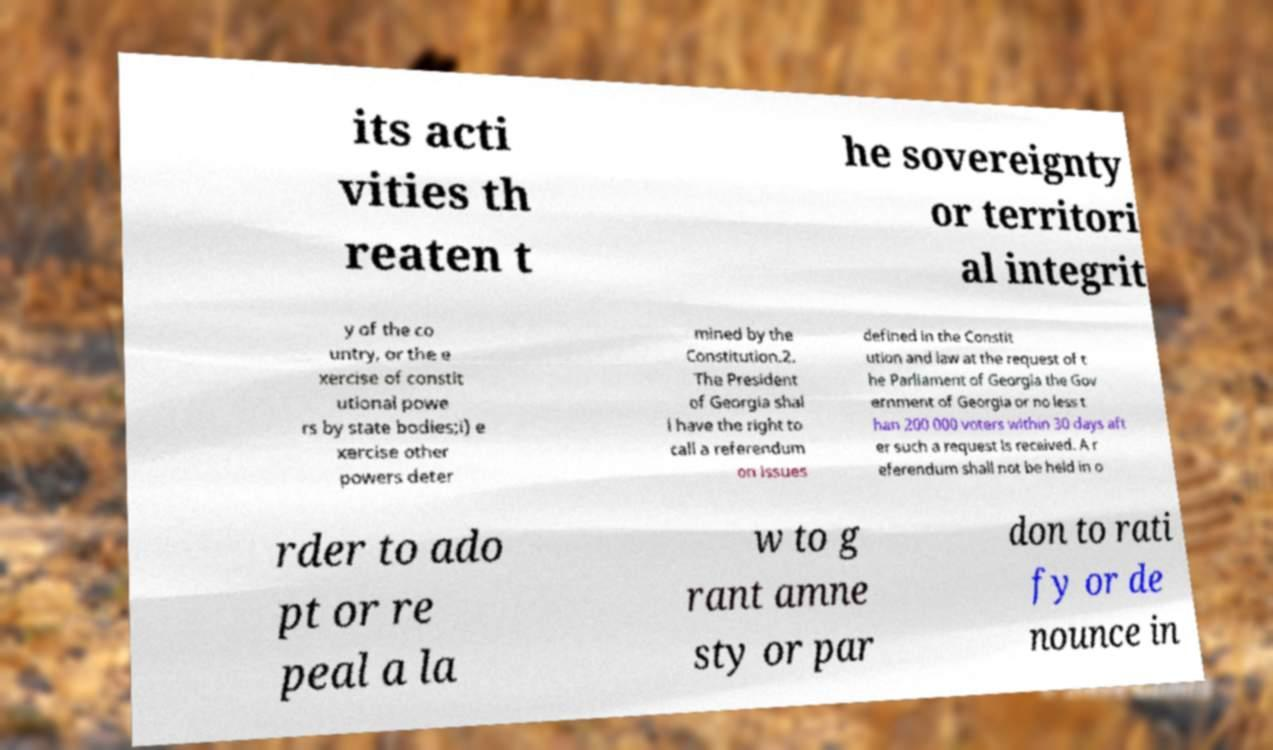Please identify and transcribe the text found in this image. its acti vities th reaten t he sovereignty or territori al integrit y of the co untry, or the e xercise of constit utional powe rs by state bodies;i) e xercise other powers deter mined by the Constitution.2. The President of Georgia shal l have the right to call a referendum on issues defined in the Constit ution and law at the request of t he Parliament of Georgia the Gov ernment of Georgia or no less t han 200 000 voters within 30 days aft er such a request is received. A r eferendum shall not be held in o rder to ado pt or re peal a la w to g rant amne sty or par don to rati fy or de nounce in 